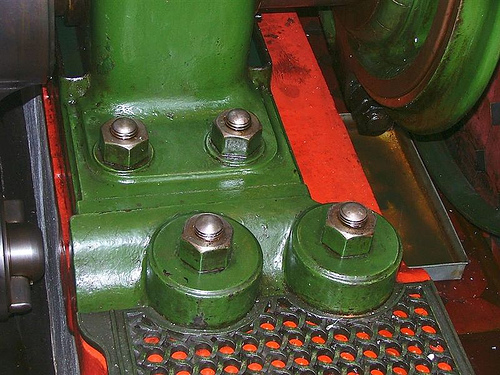<image>
Is there a nut to the left of the tread? No. The nut is not to the left of the tread. From this viewpoint, they have a different horizontal relationship. 